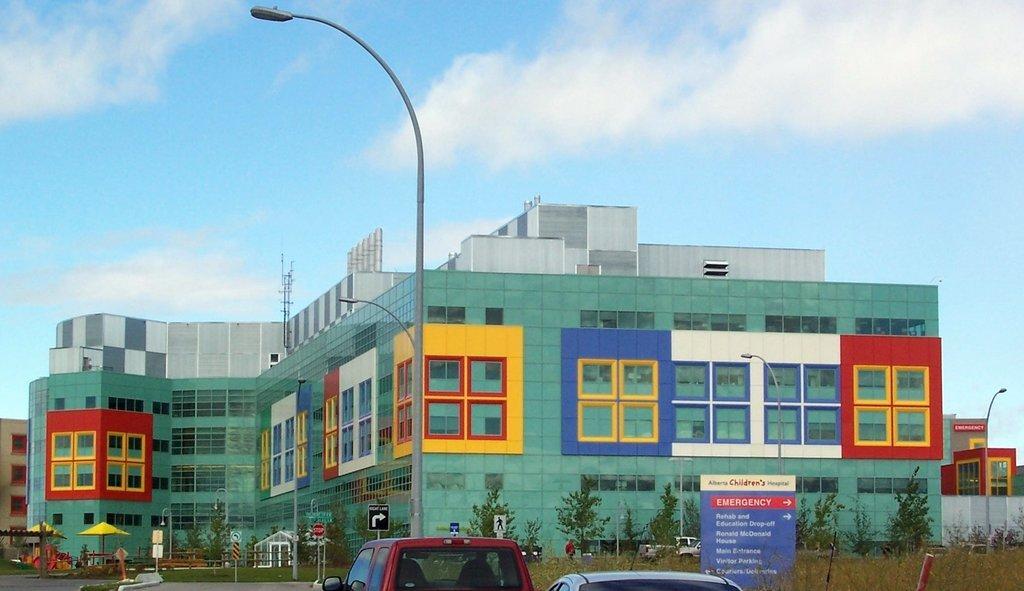Please provide a concise description of this image. This picture is clicked outside. In the foreground we can see the cars seems to be parked on the ground and we can see the grass, trees, text on the boards and we can see the lamp posts, buildings, tents and some other objects. In the background we can see the sky and the buildings. In the right corner we can see the plants. 